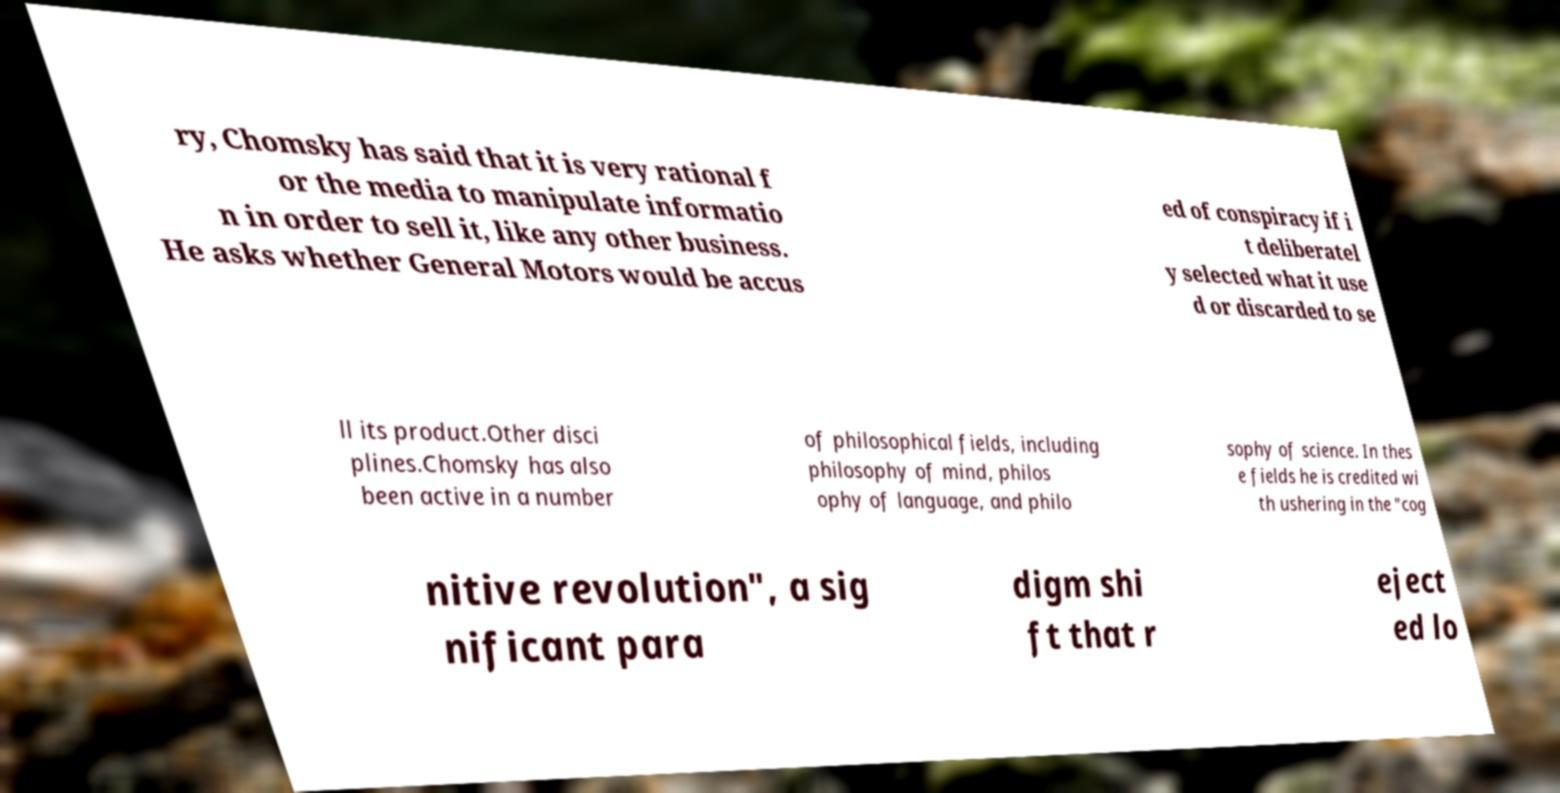For documentation purposes, I need the text within this image transcribed. Could you provide that? ry, Chomsky has said that it is very rational f or the media to manipulate informatio n in order to sell it, like any other business. He asks whether General Motors would be accus ed of conspiracy if i t deliberatel y selected what it use d or discarded to se ll its product.Other disci plines.Chomsky has also been active in a number of philosophical fields, including philosophy of mind, philos ophy of language, and philo sophy of science. In thes e fields he is credited wi th ushering in the "cog nitive revolution", a sig nificant para digm shi ft that r eject ed lo 